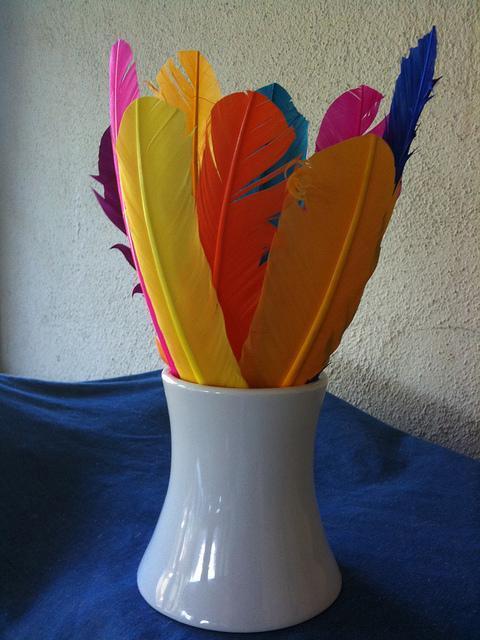How many feathers are there?
Give a very brief answer. 9. 